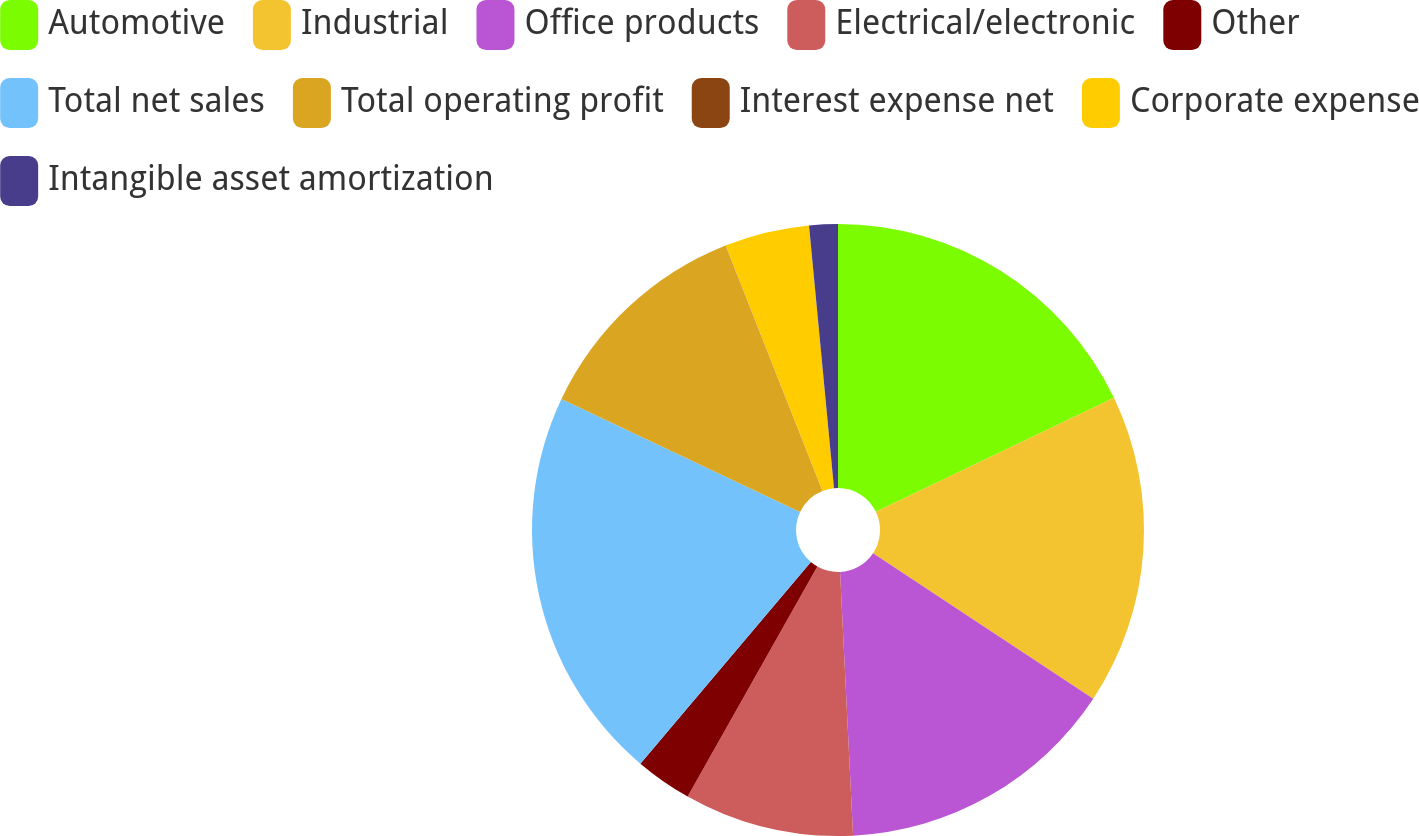Convert chart. <chart><loc_0><loc_0><loc_500><loc_500><pie_chart><fcel>Automotive<fcel>Industrial<fcel>Office products<fcel>Electrical/electronic<fcel>Other<fcel>Total net sales<fcel>Total operating profit<fcel>Interest expense net<fcel>Corporate expense<fcel>Intangible asset amortization<nl><fcel>17.89%<fcel>16.41%<fcel>14.92%<fcel>8.96%<fcel>3.0%<fcel>20.87%<fcel>11.94%<fcel>0.02%<fcel>4.49%<fcel>1.51%<nl></chart> 